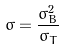Convert formula to latex. <formula><loc_0><loc_0><loc_500><loc_500>\sigma = \frac { \sigma _ { B } ^ { 2 } } { \sigma _ { T } }</formula> 